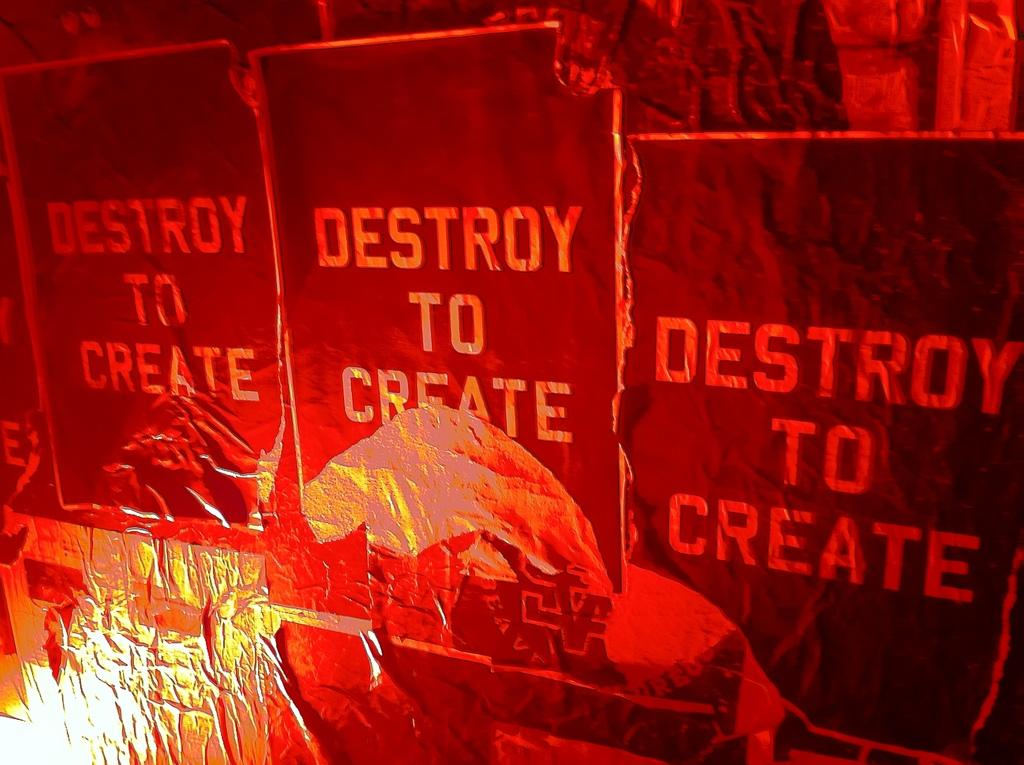What can be seen in the image? There are advertisements in the image. Can you describe the advertisements? Unfortunately, the provided facts do not include any details about the advertisements. Are there any other elements in the image besides the advertisements? The given facts do not mention any other elements in the image. How many times does the person in the image sneeze? There is no person present in the image, only advertisements. What time of day is depicted in the image? The provided facts do not mention any time-related information. Can you tell me what type of can is shown in the image? There is no can present in the image; it only contains advertisements. 